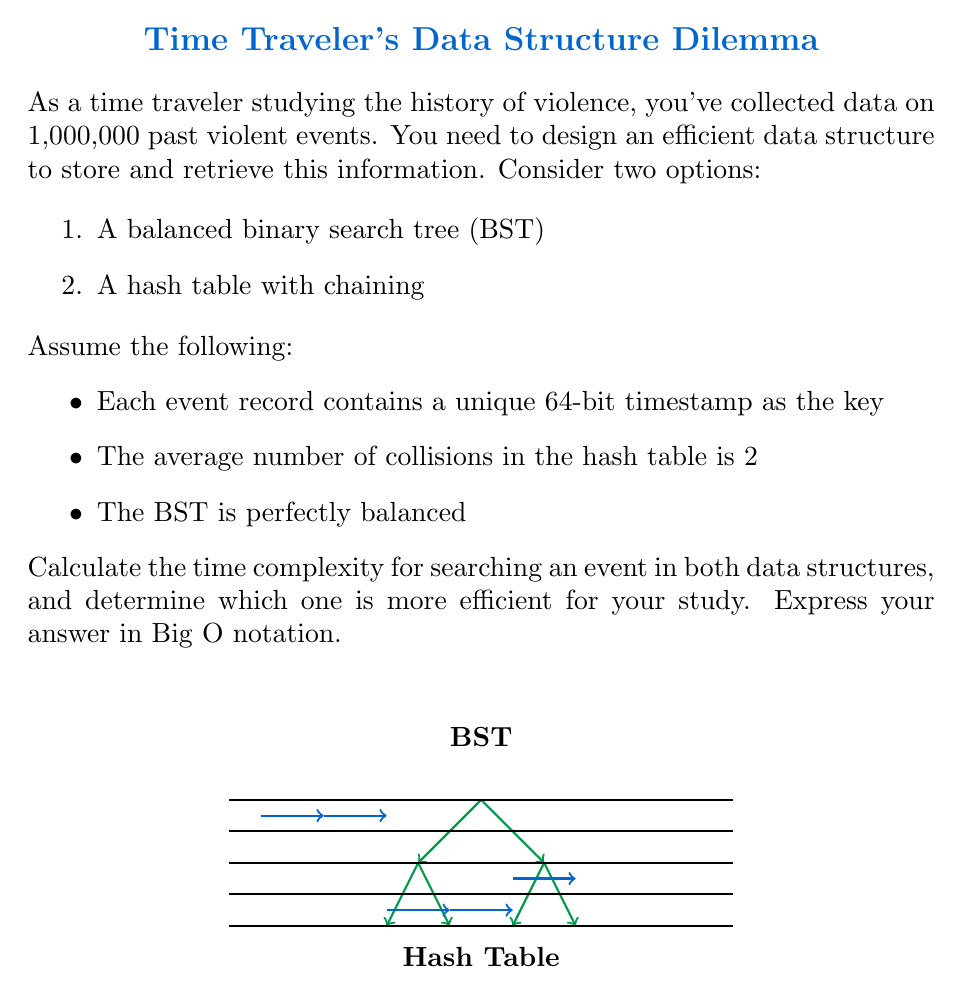Could you help me with this problem? Let's analyze the time complexity for searching an event in both data structures:

1. Balanced Binary Search Tree (BST):
   - In a perfectly balanced BST with n elements, the height of the tree is $\log_2(n)$.
   - The time complexity for searching an element is $O(\log n)$.
   - In this case, $n = 1,000,000$, so the time complexity is $O(\log 1,000,000)$.

2. Hash Table with chaining:
   - The average-case time complexity for searching in a hash table is $O(1 + \alpha)$, where $\alpha$ is the load factor.
   - The load factor $\alpha = \frac{n}{m}$, where n is the number of elements and m is the number of buckets.
   - Given that the average number of collisions is 2, we can assume $\alpha = 2$.
   - Therefore, the time complexity for searching in this hash table is $O(1 + 2) = O(3) = O(1)$.

Comparing the two:
- BST: $O(\log 1,000,000) \approx O(20)$
- Hash Table: $O(1)$

The hash table provides constant-time complexity, which is more efficient than the logarithmic time complexity of the BST, especially for large datasets like the one in this problem.

Therefore, the hash table is more efficient for storing and retrieving information on past violent events in this scenario.
Answer: $O(1)$ (Hash Table) 